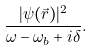Convert formula to latex. <formula><loc_0><loc_0><loc_500><loc_500>\frac { | \psi ( \vec { r } ) | ^ { 2 } } { \omega - \omega _ { b } + i \delta } .</formula> 